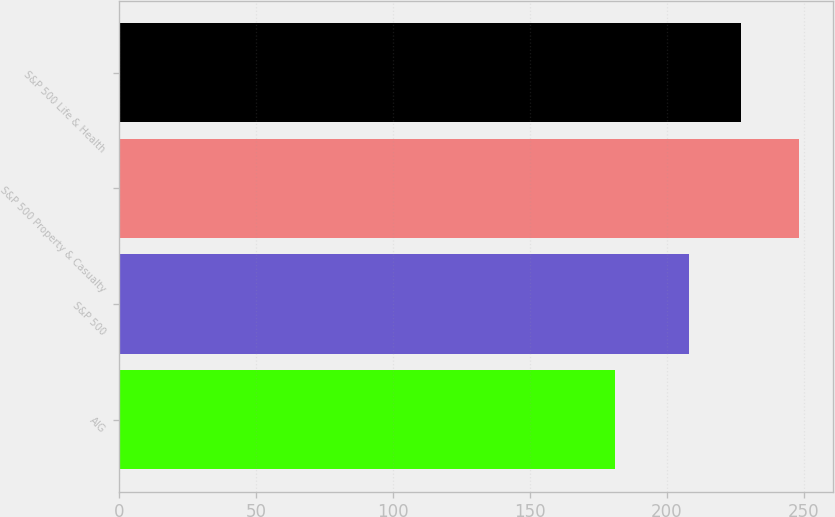Convert chart to OTSL. <chart><loc_0><loc_0><loc_500><loc_500><bar_chart><fcel>AIG<fcel>S&P 500<fcel>S&P 500 Property & Casualty<fcel>S&P 500 Life & Health<nl><fcel>181.03<fcel>208.14<fcel>248.26<fcel>226.98<nl></chart> 